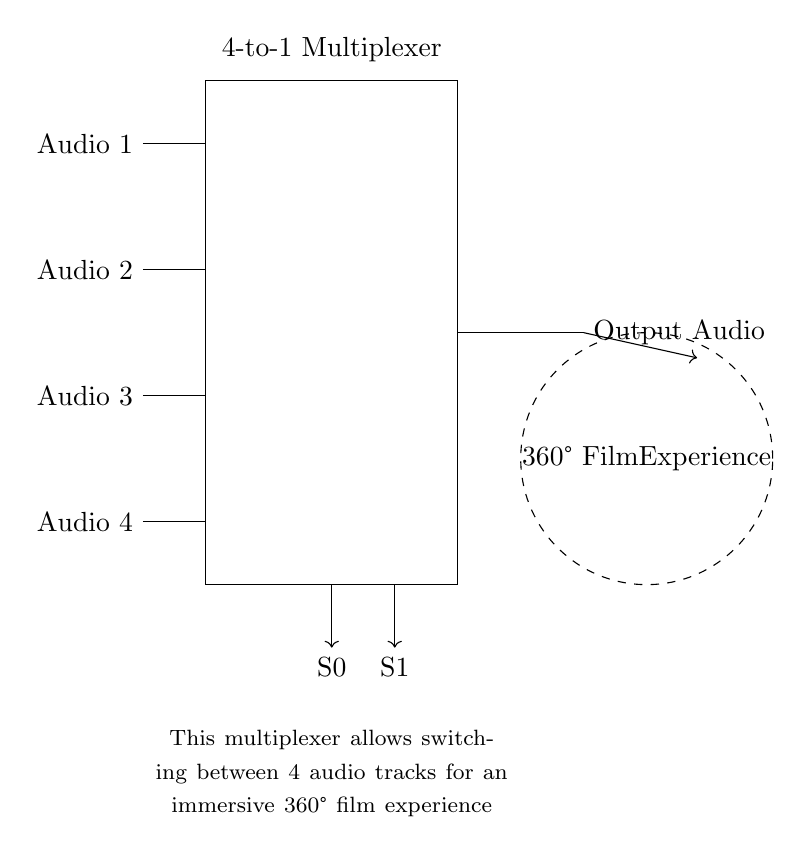What are the input audio tracks? The circuit has four input audio tracks labeled as Audio 1, Audio 2, Audio 3, and Audio 4, which are connected to the multiplexer.
Answer: Audio 1, Audio 2, Audio 3, Audio 4 What is the type of the multiplexer in this circuit? The circuit specifically indicates a 4-to-1 multiplexer, which means it has four inputs and one output based on the selection lines.
Answer: 4-to-1 How many selection lines are there? The circuit diagram shows two selection lines labeled S0 and S1, which are used to select one of the four input audio tracks to output.
Answer: 2 What does the output represent in the context of this circuit? The output of the multiplexer is labeled as Output Audio, which signifies the audio track that is currently selected to be played in the 360° film experience.
Answer: Output Audio Explain the role of the dashed circle in the diagram. The dashed circle represents the immersive 360° film experience, indicating where the selected audio track will be transferred for playback, completing the listening experience.
Answer: 360° Film Experience What is the purpose of the multiplexer in this circuit? The multiplexer allows for the selection of one audio track among four inputs based on the selection signals, enabling a dynamic audio experience for the film.
Answer: Switching audio tracks 